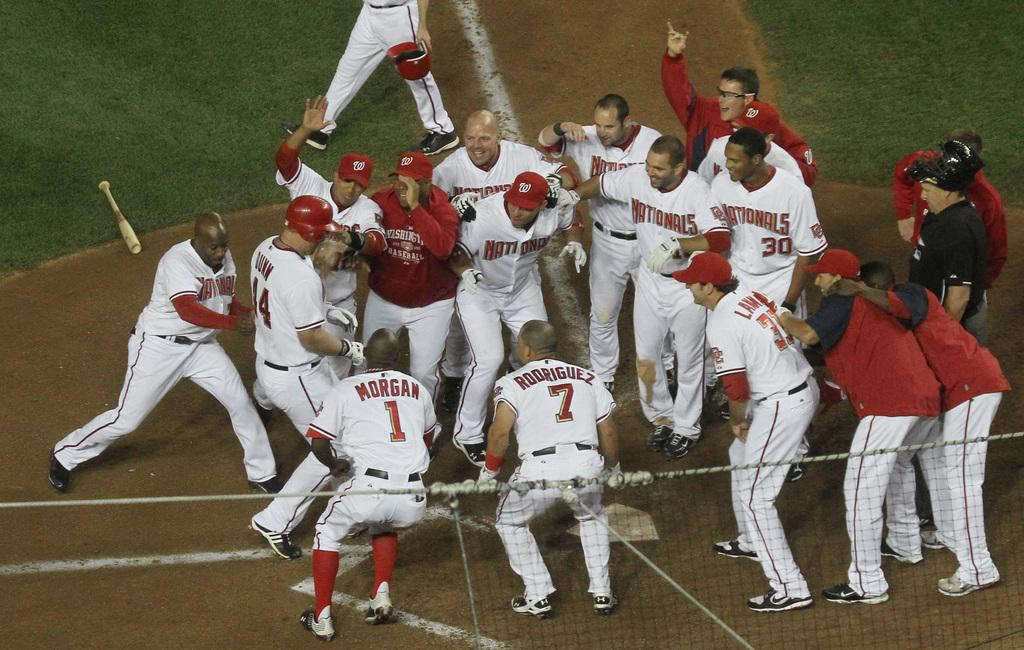<image>
Write a terse but informative summary of the picture. Morgan, Rodriguez and a bunch of other baseball players hug, clap and celebrate together. 